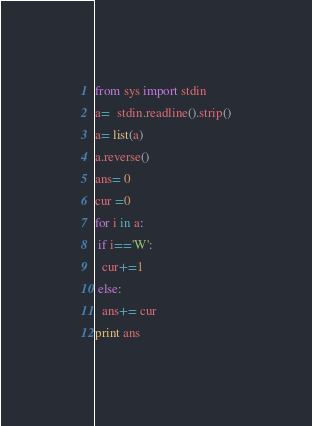<code> <loc_0><loc_0><loc_500><loc_500><_Python_>from sys import stdin
a=  stdin.readline().strip()
a= list(a)
a.reverse()
ans= 0
cur =0
for i in a:
 if i=='W':
  cur+=1
 else:
  ans+= cur
print ans</code> 